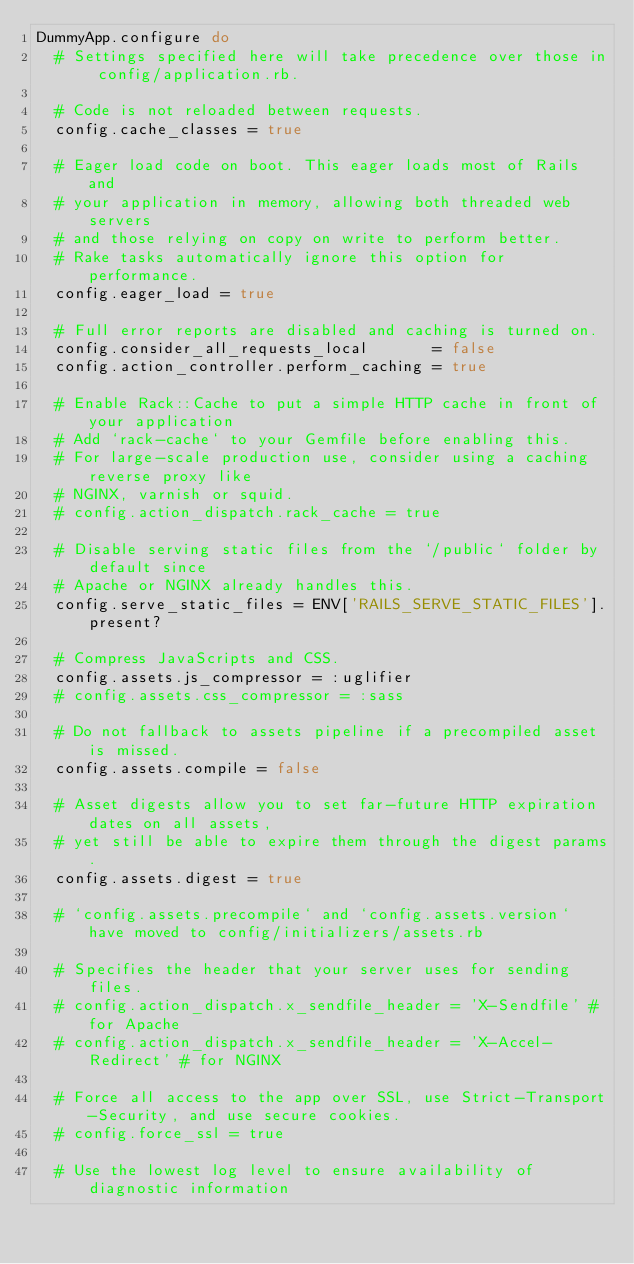<code> <loc_0><loc_0><loc_500><loc_500><_Ruby_>DummyApp.configure do
  # Settings specified here will take precedence over those in config/application.rb.

  # Code is not reloaded between requests.
  config.cache_classes = true

  # Eager load code on boot. This eager loads most of Rails and
  # your application in memory, allowing both threaded web servers
  # and those relying on copy on write to perform better.
  # Rake tasks automatically ignore this option for performance.
  config.eager_load = true

  # Full error reports are disabled and caching is turned on.
  config.consider_all_requests_local       = false
  config.action_controller.perform_caching = true

  # Enable Rack::Cache to put a simple HTTP cache in front of your application
  # Add `rack-cache` to your Gemfile before enabling this.
  # For large-scale production use, consider using a caching reverse proxy like
  # NGINX, varnish or squid.
  # config.action_dispatch.rack_cache = true

  # Disable serving static files from the `/public` folder by default since
  # Apache or NGINX already handles this.
  config.serve_static_files = ENV['RAILS_SERVE_STATIC_FILES'].present?

  # Compress JavaScripts and CSS.
  config.assets.js_compressor = :uglifier
  # config.assets.css_compressor = :sass

  # Do not fallback to assets pipeline if a precompiled asset is missed.
  config.assets.compile = false

  # Asset digests allow you to set far-future HTTP expiration dates on all assets,
  # yet still be able to expire them through the digest params.
  config.assets.digest = true

  # `config.assets.precompile` and `config.assets.version` have moved to config/initializers/assets.rb

  # Specifies the header that your server uses for sending files.
  # config.action_dispatch.x_sendfile_header = 'X-Sendfile' # for Apache
  # config.action_dispatch.x_sendfile_header = 'X-Accel-Redirect' # for NGINX

  # Force all access to the app over SSL, use Strict-Transport-Security, and use secure cookies.
  # config.force_ssl = true

  # Use the lowest log level to ensure availability of diagnostic information</code> 